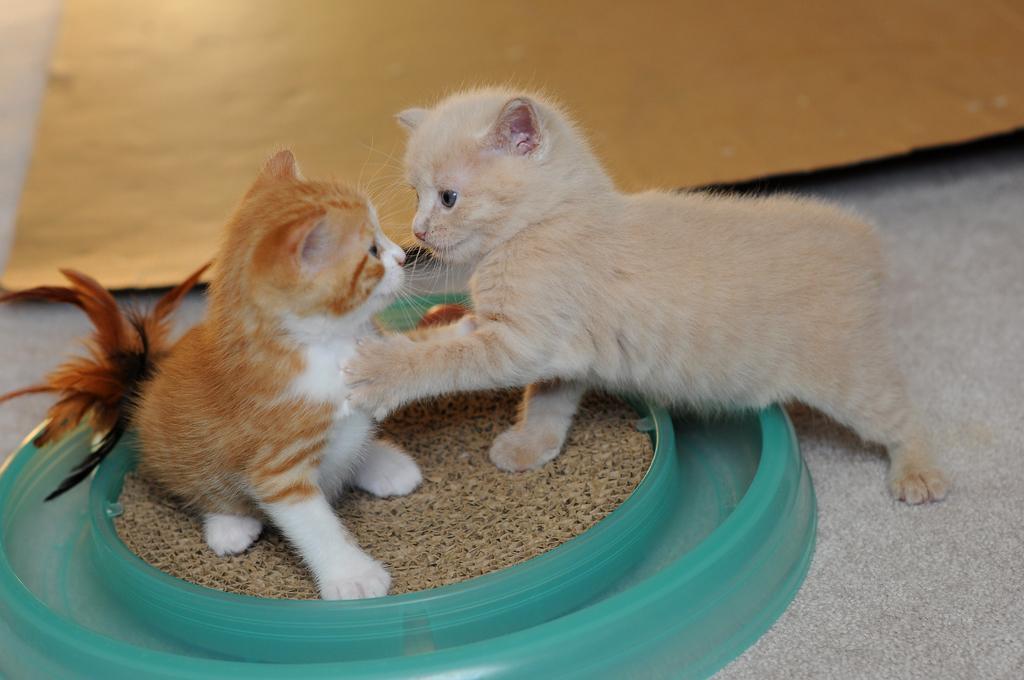Please provide a concise description of this image. In this image we can see the two cats on an object which is on the surface. We can also see the sheet on the floor. 